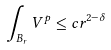<formula> <loc_0><loc_0><loc_500><loc_500>\int _ { B _ { r } } V ^ { p } \leq c r ^ { 2 - \delta }</formula> 